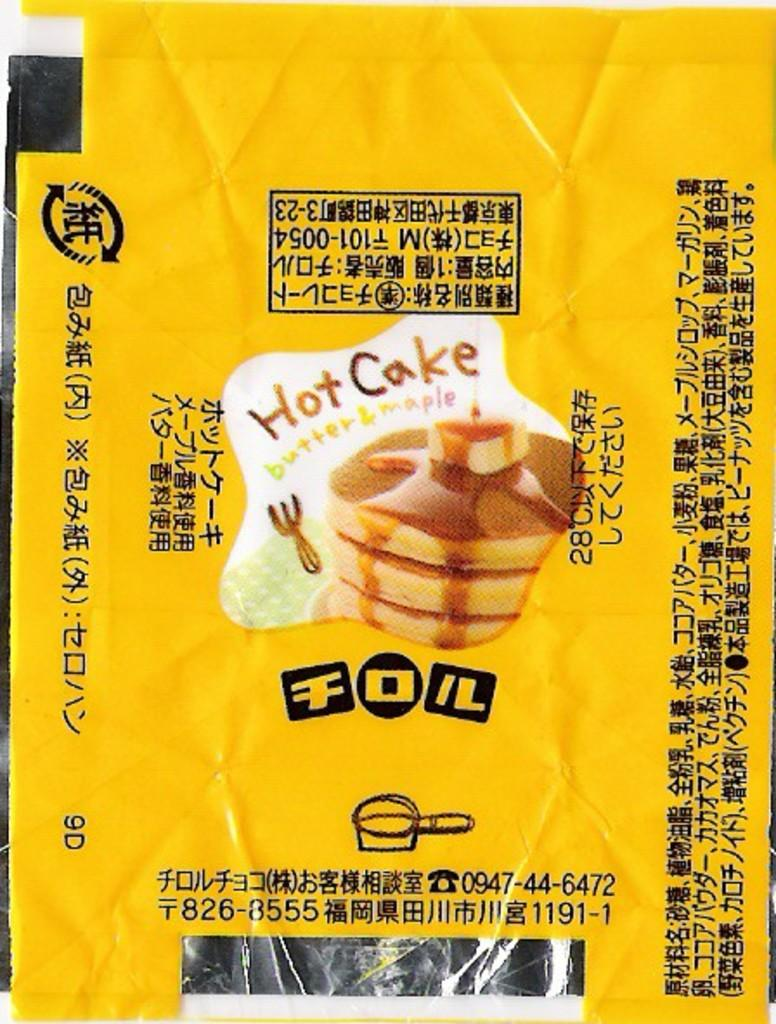<image>
Summarize the visual content of the image. A food package with a "Hot Cake" sticker on it has writing mostly in Japanese. 